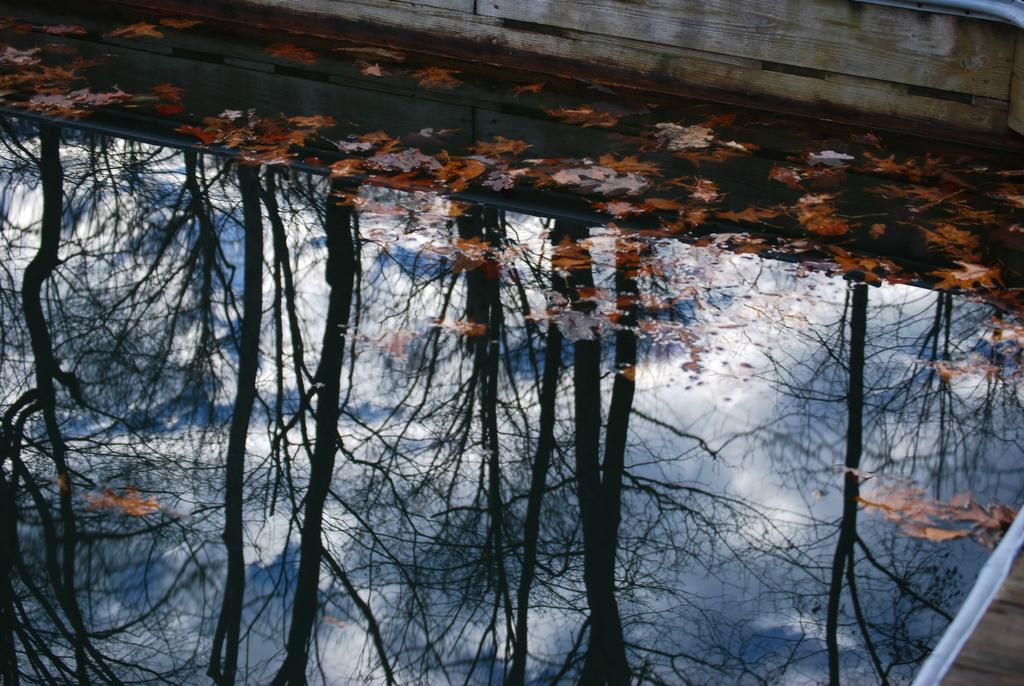What is visible in the image? Water and leaves are visible in the image. What is the relationship between the trees and the water in the image? The trees are present in the image, and their reflection is visible in the water. What type of society can be seen interacting with the monkey in the image? There is no society or monkey present in the image; it features water and leaves with the reflection of trees. 